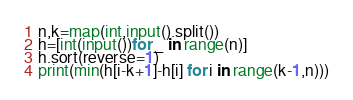<code> <loc_0><loc_0><loc_500><loc_500><_Python_>n,k=map(int,input().split())
h=[int(input())for _ in range(n)]
h.sort(reverse=1)
print(min(h[i-k+1]-h[i] for i in range(k-1,n)))</code> 